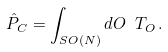<formula> <loc_0><loc_0><loc_500><loc_500>\hat { P } _ { C } = \int _ { S O ( N ) } d O \ T _ { O } \, .</formula> 